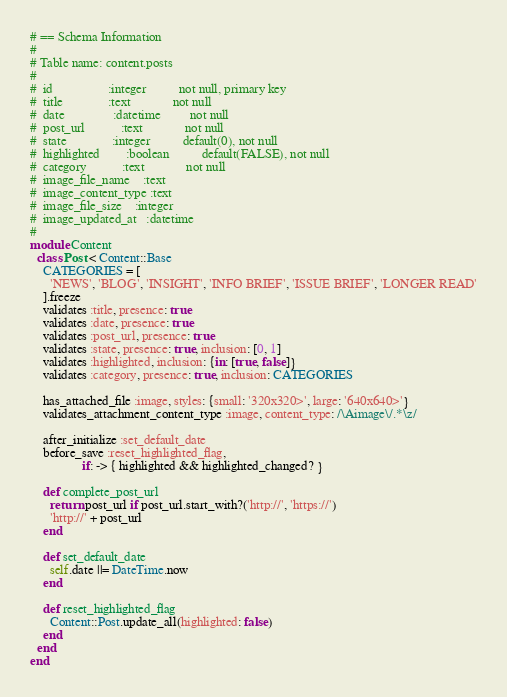Convert code to text. <code><loc_0><loc_0><loc_500><loc_500><_Ruby_># == Schema Information
#
# Table name: content.posts
#
#  id                 :integer          not null, primary key
#  title              :text             not null
#  date               :datetime         not null
#  post_url           :text             not null
#  state              :integer          default(0), not null
#  highlighted        :boolean          default(FALSE), not null
#  category           :text             not null
#  image_file_name    :text
#  image_content_type :text
#  image_file_size    :integer
#  image_updated_at   :datetime
#
module Content
  class Post < Content::Base
    CATEGORIES = [
      'NEWS', 'BLOG', 'INSIGHT', 'INFO BRIEF', 'ISSUE BRIEF', 'LONGER READ'
    ].freeze
    validates :title, presence: true
    validates :date, presence: true
    validates :post_url, presence: true
    validates :state, presence: true, inclusion: [0, 1]
    validates :highlighted, inclusion: {in: [true, false]}
    validates :category, presence: true, inclusion: CATEGORIES

    has_attached_file :image, styles: {small: '320x320>', large: '640x640>'}
    validates_attachment_content_type :image, content_type: /\Aimage\/.*\z/

    after_initialize :set_default_date
    before_save :reset_highlighted_flag,
                if: -> { highlighted && highlighted_changed? }

    def complete_post_url
      return post_url if post_url.start_with?('http://', 'https://')
      'http://' + post_url
    end

    def set_default_date
      self.date ||= DateTime.now
    end

    def reset_highlighted_flag
      Content::Post.update_all(highlighted: false)
    end
  end
end
</code> 